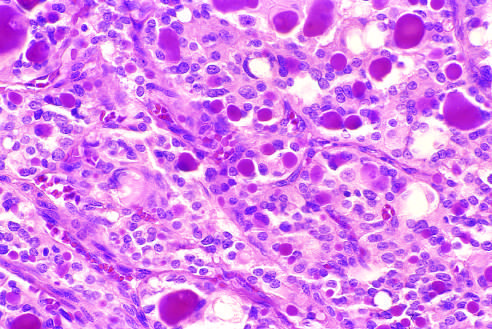what do a few of the glandular lumina contain?
Answer the question using a single word or phrase. Recognizable colloid 